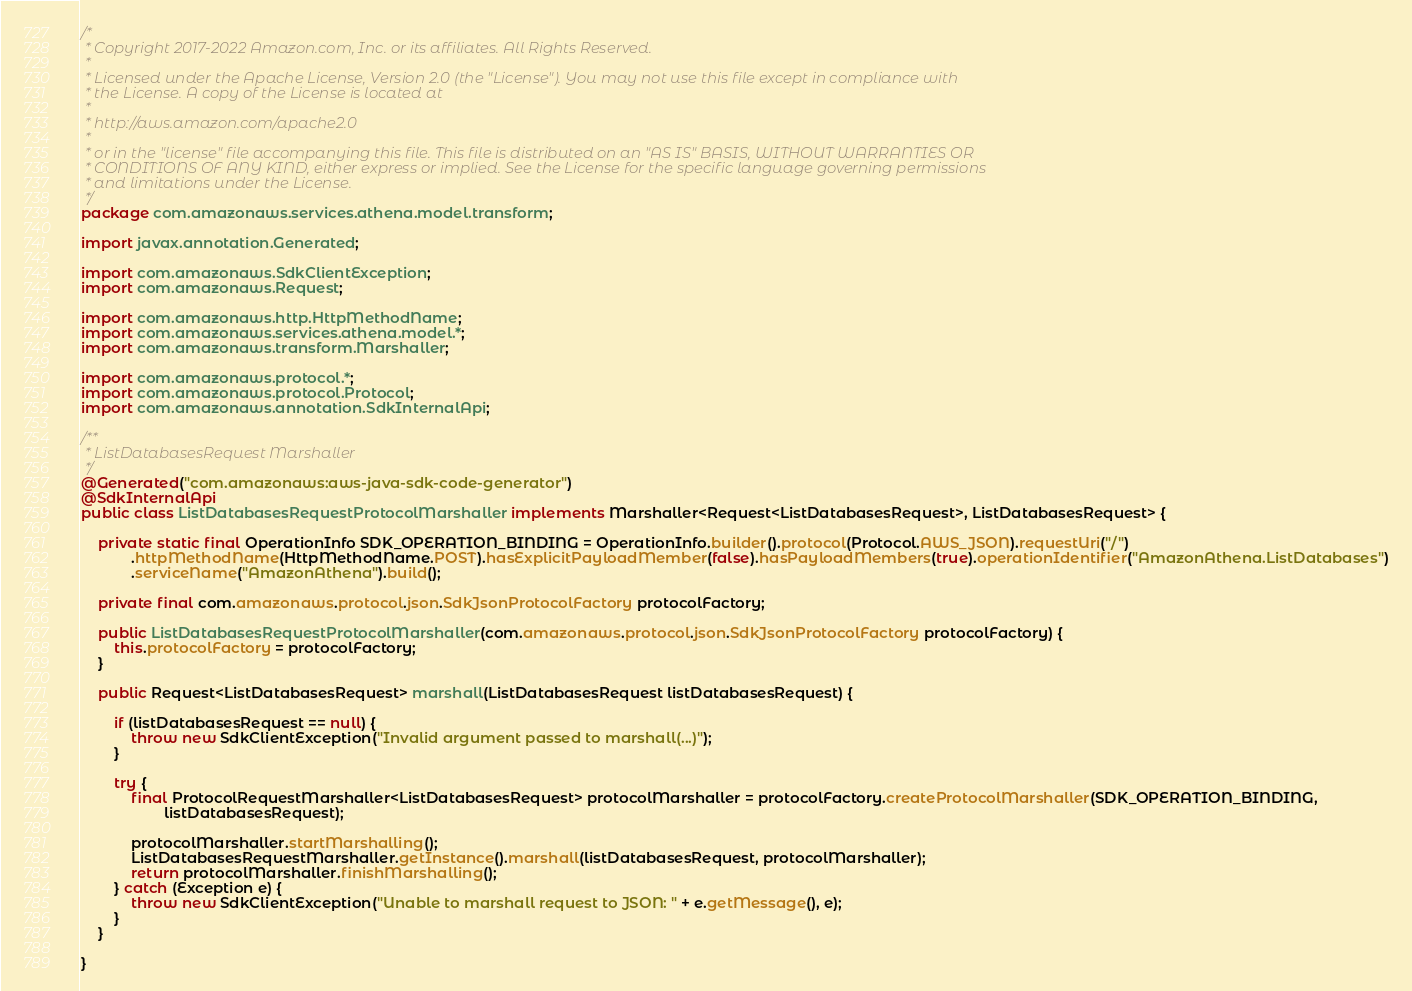<code> <loc_0><loc_0><loc_500><loc_500><_Java_>/*
 * Copyright 2017-2022 Amazon.com, Inc. or its affiliates. All Rights Reserved.
 * 
 * Licensed under the Apache License, Version 2.0 (the "License"). You may not use this file except in compliance with
 * the License. A copy of the License is located at
 * 
 * http://aws.amazon.com/apache2.0
 * 
 * or in the "license" file accompanying this file. This file is distributed on an "AS IS" BASIS, WITHOUT WARRANTIES OR
 * CONDITIONS OF ANY KIND, either express or implied. See the License for the specific language governing permissions
 * and limitations under the License.
 */
package com.amazonaws.services.athena.model.transform;

import javax.annotation.Generated;

import com.amazonaws.SdkClientException;
import com.amazonaws.Request;

import com.amazonaws.http.HttpMethodName;
import com.amazonaws.services.athena.model.*;
import com.amazonaws.transform.Marshaller;

import com.amazonaws.protocol.*;
import com.amazonaws.protocol.Protocol;
import com.amazonaws.annotation.SdkInternalApi;

/**
 * ListDatabasesRequest Marshaller
 */
@Generated("com.amazonaws:aws-java-sdk-code-generator")
@SdkInternalApi
public class ListDatabasesRequestProtocolMarshaller implements Marshaller<Request<ListDatabasesRequest>, ListDatabasesRequest> {

    private static final OperationInfo SDK_OPERATION_BINDING = OperationInfo.builder().protocol(Protocol.AWS_JSON).requestUri("/")
            .httpMethodName(HttpMethodName.POST).hasExplicitPayloadMember(false).hasPayloadMembers(true).operationIdentifier("AmazonAthena.ListDatabases")
            .serviceName("AmazonAthena").build();

    private final com.amazonaws.protocol.json.SdkJsonProtocolFactory protocolFactory;

    public ListDatabasesRequestProtocolMarshaller(com.amazonaws.protocol.json.SdkJsonProtocolFactory protocolFactory) {
        this.protocolFactory = protocolFactory;
    }

    public Request<ListDatabasesRequest> marshall(ListDatabasesRequest listDatabasesRequest) {

        if (listDatabasesRequest == null) {
            throw new SdkClientException("Invalid argument passed to marshall(...)");
        }

        try {
            final ProtocolRequestMarshaller<ListDatabasesRequest> protocolMarshaller = protocolFactory.createProtocolMarshaller(SDK_OPERATION_BINDING,
                    listDatabasesRequest);

            protocolMarshaller.startMarshalling();
            ListDatabasesRequestMarshaller.getInstance().marshall(listDatabasesRequest, protocolMarshaller);
            return protocolMarshaller.finishMarshalling();
        } catch (Exception e) {
            throw new SdkClientException("Unable to marshall request to JSON: " + e.getMessage(), e);
        }
    }

}
</code> 